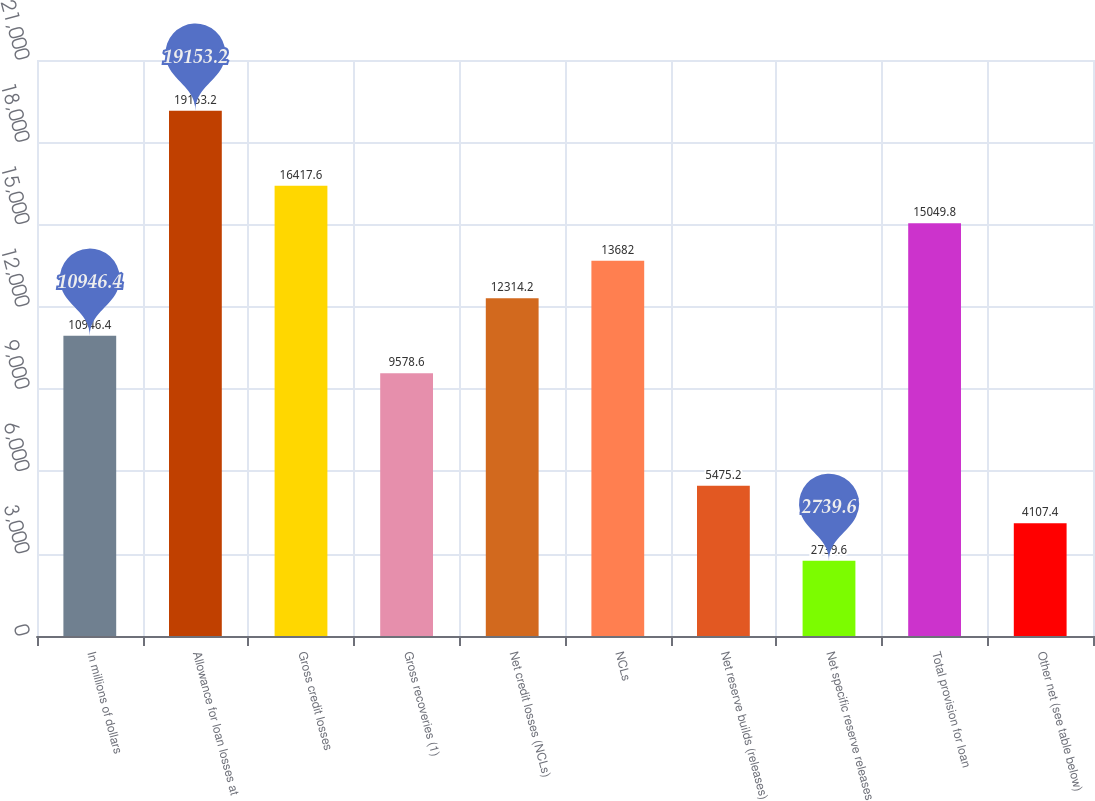<chart> <loc_0><loc_0><loc_500><loc_500><bar_chart><fcel>In millions of dollars<fcel>Allowance for loan losses at<fcel>Gross credit losses<fcel>Gross recoveries (1)<fcel>Net credit losses (NCLs)<fcel>NCLs<fcel>Net reserve builds (releases)<fcel>Net specific reserve releases<fcel>Total provision for loan<fcel>Other net (see table below)<nl><fcel>10946.4<fcel>19153.2<fcel>16417.6<fcel>9578.6<fcel>12314.2<fcel>13682<fcel>5475.2<fcel>2739.6<fcel>15049.8<fcel>4107.4<nl></chart> 